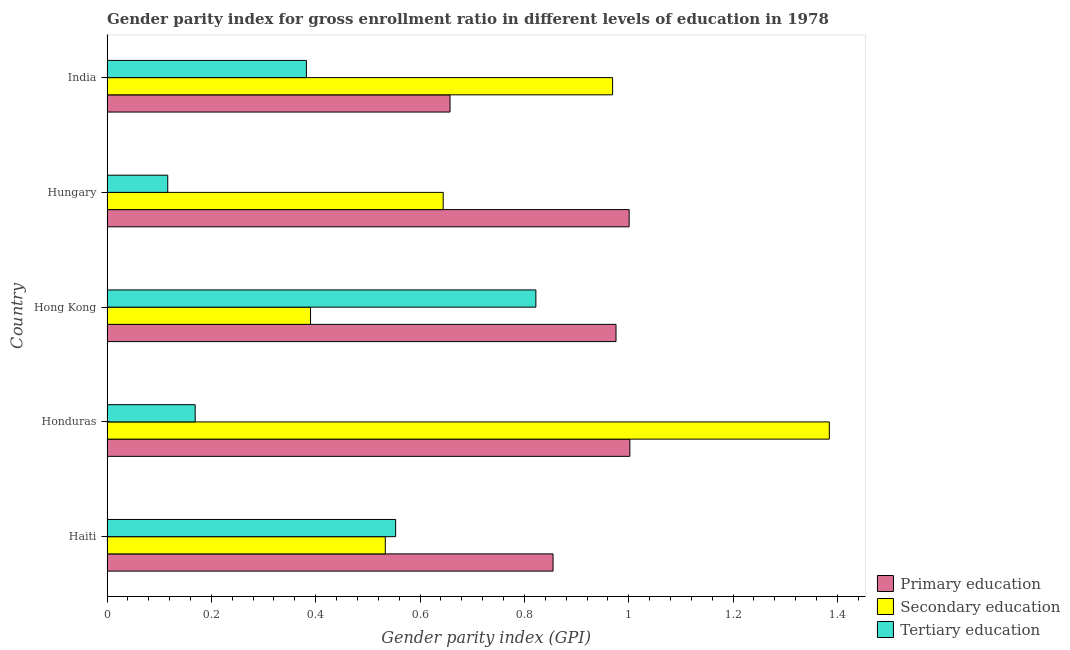Are the number of bars per tick equal to the number of legend labels?
Your answer should be compact. Yes. How many bars are there on the 5th tick from the top?
Offer a terse response. 3. How many bars are there on the 4th tick from the bottom?
Provide a succinct answer. 3. What is the label of the 3rd group of bars from the top?
Give a very brief answer. Hong Kong. What is the gender parity index in secondary education in Honduras?
Offer a very short reply. 1.38. Across all countries, what is the maximum gender parity index in tertiary education?
Make the answer very short. 0.82. Across all countries, what is the minimum gender parity index in secondary education?
Offer a terse response. 0.39. In which country was the gender parity index in primary education maximum?
Offer a very short reply. Honduras. In which country was the gender parity index in tertiary education minimum?
Offer a very short reply. Hungary. What is the total gender parity index in secondary education in the graph?
Provide a succinct answer. 3.92. What is the difference between the gender parity index in tertiary education in Hungary and that in India?
Your answer should be very brief. -0.27. What is the difference between the gender parity index in tertiary education in Hungary and the gender parity index in primary education in India?
Ensure brevity in your answer.  -0.54. What is the average gender parity index in secondary education per country?
Offer a terse response. 0.78. What is the difference between the gender parity index in tertiary education and gender parity index in primary education in Honduras?
Keep it short and to the point. -0.83. In how many countries, is the gender parity index in primary education greater than 0.52 ?
Your answer should be compact. 5. What is the ratio of the gender parity index in secondary education in Honduras to that in Hong Kong?
Your answer should be compact. 3.55. Is the gender parity index in tertiary education in Honduras less than that in Hong Kong?
Your answer should be compact. Yes. Is the difference between the gender parity index in secondary education in Haiti and Hungary greater than the difference between the gender parity index in primary education in Haiti and Hungary?
Make the answer very short. Yes. What is the difference between the highest and the second highest gender parity index in primary education?
Ensure brevity in your answer.  0. What is the difference between the highest and the lowest gender parity index in tertiary education?
Provide a short and direct response. 0.71. What does the 2nd bar from the top in India represents?
Offer a terse response. Secondary education. What does the 3rd bar from the bottom in Hong Kong represents?
Make the answer very short. Tertiary education. Is it the case that in every country, the sum of the gender parity index in primary education and gender parity index in secondary education is greater than the gender parity index in tertiary education?
Your answer should be compact. Yes. What is the difference between two consecutive major ticks on the X-axis?
Ensure brevity in your answer.  0.2. Are the values on the major ticks of X-axis written in scientific E-notation?
Provide a succinct answer. No. Does the graph contain grids?
Make the answer very short. No. Where does the legend appear in the graph?
Offer a very short reply. Bottom right. How are the legend labels stacked?
Ensure brevity in your answer.  Vertical. What is the title of the graph?
Your answer should be compact. Gender parity index for gross enrollment ratio in different levels of education in 1978. Does "Ages 15-20" appear as one of the legend labels in the graph?
Keep it short and to the point. No. What is the label or title of the X-axis?
Keep it short and to the point. Gender parity index (GPI). What is the Gender parity index (GPI) of Primary education in Haiti?
Provide a succinct answer. 0.85. What is the Gender parity index (GPI) in Secondary education in Haiti?
Give a very brief answer. 0.53. What is the Gender parity index (GPI) in Tertiary education in Haiti?
Provide a short and direct response. 0.55. What is the Gender parity index (GPI) of Primary education in Honduras?
Provide a short and direct response. 1. What is the Gender parity index (GPI) of Secondary education in Honduras?
Your answer should be compact. 1.38. What is the Gender parity index (GPI) of Tertiary education in Honduras?
Your answer should be compact. 0.17. What is the Gender parity index (GPI) of Primary education in Hong Kong?
Your answer should be very brief. 0.98. What is the Gender parity index (GPI) of Secondary education in Hong Kong?
Make the answer very short. 0.39. What is the Gender parity index (GPI) of Tertiary education in Hong Kong?
Ensure brevity in your answer.  0.82. What is the Gender parity index (GPI) of Primary education in Hungary?
Provide a succinct answer. 1. What is the Gender parity index (GPI) of Secondary education in Hungary?
Your answer should be compact. 0.64. What is the Gender parity index (GPI) in Tertiary education in Hungary?
Your answer should be very brief. 0.12. What is the Gender parity index (GPI) of Primary education in India?
Keep it short and to the point. 0.66. What is the Gender parity index (GPI) in Secondary education in India?
Make the answer very short. 0.97. What is the Gender parity index (GPI) in Tertiary education in India?
Offer a very short reply. 0.38. Across all countries, what is the maximum Gender parity index (GPI) in Primary education?
Ensure brevity in your answer.  1. Across all countries, what is the maximum Gender parity index (GPI) in Secondary education?
Offer a very short reply. 1.38. Across all countries, what is the maximum Gender parity index (GPI) in Tertiary education?
Provide a short and direct response. 0.82. Across all countries, what is the minimum Gender parity index (GPI) of Primary education?
Provide a succinct answer. 0.66. Across all countries, what is the minimum Gender parity index (GPI) of Secondary education?
Your answer should be very brief. 0.39. Across all countries, what is the minimum Gender parity index (GPI) of Tertiary education?
Offer a terse response. 0.12. What is the total Gender parity index (GPI) of Primary education in the graph?
Your response must be concise. 4.49. What is the total Gender parity index (GPI) in Secondary education in the graph?
Keep it short and to the point. 3.92. What is the total Gender parity index (GPI) of Tertiary education in the graph?
Your answer should be compact. 2.04. What is the difference between the Gender parity index (GPI) in Primary education in Haiti and that in Honduras?
Ensure brevity in your answer.  -0.15. What is the difference between the Gender parity index (GPI) in Secondary education in Haiti and that in Honduras?
Keep it short and to the point. -0.85. What is the difference between the Gender parity index (GPI) in Tertiary education in Haiti and that in Honduras?
Ensure brevity in your answer.  0.38. What is the difference between the Gender parity index (GPI) of Primary education in Haiti and that in Hong Kong?
Offer a very short reply. -0.12. What is the difference between the Gender parity index (GPI) of Secondary education in Haiti and that in Hong Kong?
Offer a terse response. 0.14. What is the difference between the Gender parity index (GPI) in Tertiary education in Haiti and that in Hong Kong?
Make the answer very short. -0.27. What is the difference between the Gender parity index (GPI) of Primary education in Haiti and that in Hungary?
Ensure brevity in your answer.  -0.15. What is the difference between the Gender parity index (GPI) in Secondary education in Haiti and that in Hungary?
Make the answer very short. -0.11. What is the difference between the Gender parity index (GPI) in Tertiary education in Haiti and that in Hungary?
Ensure brevity in your answer.  0.44. What is the difference between the Gender parity index (GPI) in Primary education in Haiti and that in India?
Give a very brief answer. 0.2. What is the difference between the Gender parity index (GPI) of Secondary education in Haiti and that in India?
Your answer should be very brief. -0.44. What is the difference between the Gender parity index (GPI) in Tertiary education in Haiti and that in India?
Provide a short and direct response. 0.17. What is the difference between the Gender parity index (GPI) of Primary education in Honduras and that in Hong Kong?
Offer a very short reply. 0.03. What is the difference between the Gender parity index (GPI) of Tertiary education in Honduras and that in Hong Kong?
Offer a terse response. -0.65. What is the difference between the Gender parity index (GPI) in Primary education in Honduras and that in Hungary?
Provide a short and direct response. 0. What is the difference between the Gender parity index (GPI) of Secondary education in Honduras and that in Hungary?
Your response must be concise. 0.74. What is the difference between the Gender parity index (GPI) in Tertiary education in Honduras and that in Hungary?
Your answer should be compact. 0.05. What is the difference between the Gender parity index (GPI) in Primary education in Honduras and that in India?
Your response must be concise. 0.34. What is the difference between the Gender parity index (GPI) of Secondary education in Honduras and that in India?
Ensure brevity in your answer.  0.42. What is the difference between the Gender parity index (GPI) in Tertiary education in Honduras and that in India?
Give a very brief answer. -0.21. What is the difference between the Gender parity index (GPI) of Primary education in Hong Kong and that in Hungary?
Offer a very short reply. -0.03. What is the difference between the Gender parity index (GPI) of Secondary education in Hong Kong and that in Hungary?
Offer a terse response. -0.25. What is the difference between the Gender parity index (GPI) of Tertiary education in Hong Kong and that in Hungary?
Keep it short and to the point. 0.71. What is the difference between the Gender parity index (GPI) in Primary education in Hong Kong and that in India?
Give a very brief answer. 0.32. What is the difference between the Gender parity index (GPI) of Secondary education in Hong Kong and that in India?
Keep it short and to the point. -0.58. What is the difference between the Gender parity index (GPI) in Tertiary education in Hong Kong and that in India?
Provide a short and direct response. 0.44. What is the difference between the Gender parity index (GPI) of Primary education in Hungary and that in India?
Give a very brief answer. 0.34. What is the difference between the Gender parity index (GPI) of Secondary education in Hungary and that in India?
Your answer should be compact. -0.32. What is the difference between the Gender parity index (GPI) in Tertiary education in Hungary and that in India?
Give a very brief answer. -0.27. What is the difference between the Gender parity index (GPI) in Primary education in Haiti and the Gender parity index (GPI) in Secondary education in Honduras?
Provide a short and direct response. -0.53. What is the difference between the Gender parity index (GPI) in Primary education in Haiti and the Gender parity index (GPI) in Tertiary education in Honduras?
Provide a short and direct response. 0.69. What is the difference between the Gender parity index (GPI) of Secondary education in Haiti and the Gender parity index (GPI) of Tertiary education in Honduras?
Ensure brevity in your answer.  0.36. What is the difference between the Gender parity index (GPI) of Primary education in Haiti and the Gender parity index (GPI) of Secondary education in Hong Kong?
Ensure brevity in your answer.  0.46. What is the difference between the Gender parity index (GPI) of Primary education in Haiti and the Gender parity index (GPI) of Tertiary education in Hong Kong?
Provide a short and direct response. 0.03. What is the difference between the Gender parity index (GPI) of Secondary education in Haiti and the Gender parity index (GPI) of Tertiary education in Hong Kong?
Provide a succinct answer. -0.29. What is the difference between the Gender parity index (GPI) of Primary education in Haiti and the Gender parity index (GPI) of Secondary education in Hungary?
Give a very brief answer. 0.21. What is the difference between the Gender parity index (GPI) in Primary education in Haiti and the Gender parity index (GPI) in Tertiary education in Hungary?
Give a very brief answer. 0.74. What is the difference between the Gender parity index (GPI) of Secondary education in Haiti and the Gender parity index (GPI) of Tertiary education in Hungary?
Give a very brief answer. 0.42. What is the difference between the Gender parity index (GPI) of Primary education in Haiti and the Gender parity index (GPI) of Secondary education in India?
Offer a very short reply. -0.11. What is the difference between the Gender parity index (GPI) of Primary education in Haiti and the Gender parity index (GPI) of Tertiary education in India?
Your response must be concise. 0.47. What is the difference between the Gender parity index (GPI) in Secondary education in Haiti and the Gender parity index (GPI) in Tertiary education in India?
Keep it short and to the point. 0.15. What is the difference between the Gender parity index (GPI) in Primary education in Honduras and the Gender parity index (GPI) in Secondary education in Hong Kong?
Give a very brief answer. 0.61. What is the difference between the Gender parity index (GPI) in Primary education in Honduras and the Gender parity index (GPI) in Tertiary education in Hong Kong?
Provide a succinct answer. 0.18. What is the difference between the Gender parity index (GPI) of Secondary education in Honduras and the Gender parity index (GPI) of Tertiary education in Hong Kong?
Provide a succinct answer. 0.56. What is the difference between the Gender parity index (GPI) of Primary education in Honduras and the Gender parity index (GPI) of Secondary education in Hungary?
Give a very brief answer. 0.36. What is the difference between the Gender parity index (GPI) of Primary education in Honduras and the Gender parity index (GPI) of Tertiary education in Hungary?
Offer a terse response. 0.89. What is the difference between the Gender parity index (GPI) in Secondary education in Honduras and the Gender parity index (GPI) in Tertiary education in Hungary?
Your answer should be compact. 1.27. What is the difference between the Gender parity index (GPI) of Primary education in Honduras and the Gender parity index (GPI) of Secondary education in India?
Give a very brief answer. 0.03. What is the difference between the Gender parity index (GPI) in Primary education in Honduras and the Gender parity index (GPI) in Tertiary education in India?
Your answer should be very brief. 0.62. What is the difference between the Gender parity index (GPI) in Secondary education in Honduras and the Gender parity index (GPI) in Tertiary education in India?
Your answer should be compact. 1. What is the difference between the Gender parity index (GPI) in Primary education in Hong Kong and the Gender parity index (GPI) in Secondary education in Hungary?
Provide a short and direct response. 0.33. What is the difference between the Gender parity index (GPI) of Primary education in Hong Kong and the Gender parity index (GPI) of Tertiary education in Hungary?
Make the answer very short. 0.86. What is the difference between the Gender parity index (GPI) in Secondary education in Hong Kong and the Gender parity index (GPI) in Tertiary education in Hungary?
Keep it short and to the point. 0.27. What is the difference between the Gender parity index (GPI) in Primary education in Hong Kong and the Gender parity index (GPI) in Secondary education in India?
Provide a succinct answer. 0.01. What is the difference between the Gender parity index (GPI) in Primary education in Hong Kong and the Gender parity index (GPI) in Tertiary education in India?
Offer a terse response. 0.59. What is the difference between the Gender parity index (GPI) in Secondary education in Hong Kong and the Gender parity index (GPI) in Tertiary education in India?
Offer a terse response. 0.01. What is the difference between the Gender parity index (GPI) in Primary education in Hungary and the Gender parity index (GPI) in Secondary education in India?
Make the answer very short. 0.03. What is the difference between the Gender parity index (GPI) in Primary education in Hungary and the Gender parity index (GPI) in Tertiary education in India?
Provide a succinct answer. 0.62. What is the difference between the Gender parity index (GPI) of Secondary education in Hungary and the Gender parity index (GPI) of Tertiary education in India?
Provide a short and direct response. 0.26. What is the average Gender parity index (GPI) in Primary education per country?
Provide a short and direct response. 0.9. What is the average Gender parity index (GPI) of Secondary education per country?
Keep it short and to the point. 0.78. What is the average Gender parity index (GPI) of Tertiary education per country?
Make the answer very short. 0.41. What is the difference between the Gender parity index (GPI) of Primary education and Gender parity index (GPI) of Secondary education in Haiti?
Make the answer very short. 0.32. What is the difference between the Gender parity index (GPI) of Primary education and Gender parity index (GPI) of Tertiary education in Haiti?
Keep it short and to the point. 0.3. What is the difference between the Gender parity index (GPI) in Secondary education and Gender parity index (GPI) in Tertiary education in Haiti?
Offer a terse response. -0.02. What is the difference between the Gender parity index (GPI) in Primary education and Gender parity index (GPI) in Secondary education in Honduras?
Provide a short and direct response. -0.38. What is the difference between the Gender parity index (GPI) in Primary education and Gender parity index (GPI) in Tertiary education in Honduras?
Keep it short and to the point. 0.83. What is the difference between the Gender parity index (GPI) in Secondary education and Gender parity index (GPI) in Tertiary education in Honduras?
Your answer should be very brief. 1.22. What is the difference between the Gender parity index (GPI) in Primary education and Gender parity index (GPI) in Secondary education in Hong Kong?
Offer a terse response. 0.59. What is the difference between the Gender parity index (GPI) in Primary education and Gender parity index (GPI) in Tertiary education in Hong Kong?
Offer a very short reply. 0.15. What is the difference between the Gender parity index (GPI) of Secondary education and Gender parity index (GPI) of Tertiary education in Hong Kong?
Offer a terse response. -0.43. What is the difference between the Gender parity index (GPI) of Primary education and Gender parity index (GPI) of Secondary education in Hungary?
Your answer should be very brief. 0.36. What is the difference between the Gender parity index (GPI) of Primary education and Gender parity index (GPI) of Tertiary education in Hungary?
Ensure brevity in your answer.  0.88. What is the difference between the Gender parity index (GPI) in Secondary education and Gender parity index (GPI) in Tertiary education in Hungary?
Your answer should be very brief. 0.53. What is the difference between the Gender parity index (GPI) in Primary education and Gender parity index (GPI) in Secondary education in India?
Offer a very short reply. -0.31. What is the difference between the Gender parity index (GPI) of Primary education and Gender parity index (GPI) of Tertiary education in India?
Keep it short and to the point. 0.28. What is the difference between the Gender parity index (GPI) of Secondary education and Gender parity index (GPI) of Tertiary education in India?
Ensure brevity in your answer.  0.59. What is the ratio of the Gender parity index (GPI) of Primary education in Haiti to that in Honduras?
Offer a terse response. 0.85. What is the ratio of the Gender parity index (GPI) in Secondary education in Haiti to that in Honduras?
Your answer should be very brief. 0.39. What is the ratio of the Gender parity index (GPI) in Tertiary education in Haiti to that in Honduras?
Your answer should be compact. 3.27. What is the ratio of the Gender parity index (GPI) in Primary education in Haiti to that in Hong Kong?
Keep it short and to the point. 0.88. What is the ratio of the Gender parity index (GPI) in Secondary education in Haiti to that in Hong Kong?
Your answer should be very brief. 1.37. What is the ratio of the Gender parity index (GPI) of Tertiary education in Haiti to that in Hong Kong?
Provide a succinct answer. 0.67. What is the ratio of the Gender parity index (GPI) in Primary education in Haiti to that in Hungary?
Give a very brief answer. 0.85. What is the ratio of the Gender parity index (GPI) of Secondary education in Haiti to that in Hungary?
Offer a terse response. 0.83. What is the ratio of the Gender parity index (GPI) of Tertiary education in Haiti to that in Hungary?
Offer a very short reply. 4.75. What is the ratio of the Gender parity index (GPI) in Primary education in Haiti to that in India?
Your answer should be compact. 1.3. What is the ratio of the Gender parity index (GPI) in Secondary education in Haiti to that in India?
Offer a terse response. 0.55. What is the ratio of the Gender parity index (GPI) in Tertiary education in Haiti to that in India?
Your answer should be compact. 1.45. What is the ratio of the Gender parity index (GPI) of Primary education in Honduras to that in Hong Kong?
Offer a very short reply. 1.03. What is the ratio of the Gender parity index (GPI) in Secondary education in Honduras to that in Hong Kong?
Your answer should be very brief. 3.55. What is the ratio of the Gender parity index (GPI) of Tertiary education in Honduras to that in Hong Kong?
Offer a very short reply. 0.21. What is the ratio of the Gender parity index (GPI) of Primary education in Honduras to that in Hungary?
Offer a very short reply. 1. What is the ratio of the Gender parity index (GPI) of Secondary education in Honduras to that in Hungary?
Provide a short and direct response. 2.15. What is the ratio of the Gender parity index (GPI) of Tertiary education in Honduras to that in Hungary?
Provide a short and direct response. 1.45. What is the ratio of the Gender parity index (GPI) of Primary education in Honduras to that in India?
Make the answer very short. 1.52. What is the ratio of the Gender parity index (GPI) in Secondary education in Honduras to that in India?
Your answer should be compact. 1.43. What is the ratio of the Gender parity index (GPI) of Tertiary education in Honduras to that in India?
Offer a very short reply. 0.44. What is the ratio of the Gender parity index (GPI) of Primary education in Hong Kong to that in Hungary?
Give a very brief answer. 0.97. What is the ratio of the Gender parity index (GPI) in Secondary education in Hong Kong to that in Hungary?
Your response must be concise. 0.61. What is the ratio of the Gender parity index (GPI) in Tertiary education in Hong Kong to that in Hungary?
Provide a short and direct response. 7.06. What is the ratio of the Gender parity index (GPI) of Primary education in Hong Kong to that in India?
Offer a very short reply. 1.48. What is the ratio of the Gender parity index (GPI) of Secondary education in Hong Kong to that in India?
Your response must be concise. 0.4. What is the ratio of the Gender parity index (GPI) in Tertiary education in Hong Kong to that in India?
Make the answer very short. 2.15. What is the ratio of the Gender parity index (GPI) in Primary education in Hungary to that in India?
Give a very brief answer. 1.52. What is the ratio of the Gender parity index (GPI) in Secondary education in Hungary to that in India?
Provide a short and direct response. 0.66. What is the ratio of the Gender parity index (GPI) of Tertiary education in Hungary to that in India?
Offer a very short reply. 0.3. What is the difference between the highest and the second highest Gender parity index (GPI) of Primary education?
Make the answer very short. 0. What is the difference between the highest and the second highest Gender parity index (GPI) in Secondary education?
Your answer should be compact. 0.42. What is the difference between the highest and the second highest Gender parity index (GPI) in Tertiary education?
Your answer should be very brief. 0.27. What is the difference between the highest and the lowest Gender parity index (GPI) of Primary education?
Keep it short and to the point. 0.34. What is the difference between the highest and the lowest Gender parity index (GPI) of Tertiary education?
Ensure brevity in your answer.  0.71. 